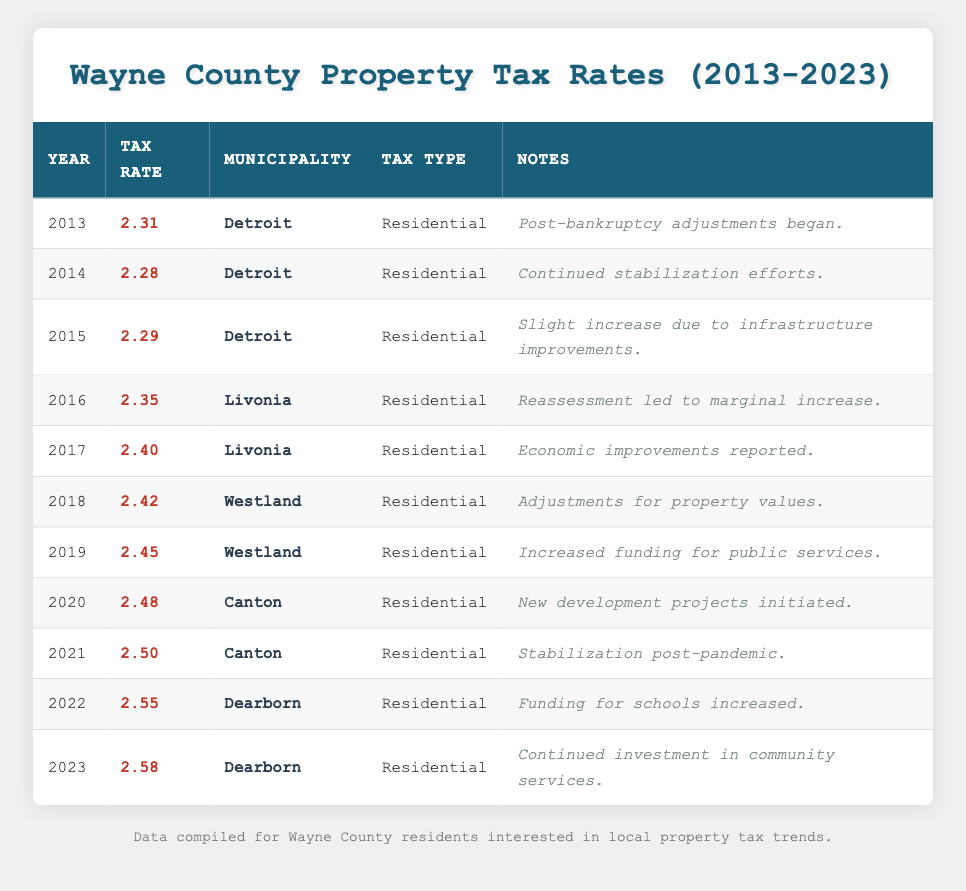What was the property tax rate in 2015 for Detroit? The table shows that in 2015, the Tax Rate for Detroit was listed as 2.29. This can be found directly under the Year 2015, in the respective row.
Answer: 2.29 What municipality had the highest property tax rate in 2021? In 2021, the Tax Rate for Canton was 2.50, making it the highest among the listed municipalities for that year, as no other municipality's rate is higher than this in the same year.
Answer: Canton Which year had the lowest property tax rate for Detroit, and what was the rate? The lowest property tax rate for Detroit was in 2014 at a rate of 2.28. By comparing the rates listed for all years pertaining to Detroit, 2014's rate is the lowest.
Answer: 2014, 2.28 What was the average property tax rate for Westland over the years 2018 and 2019? The tax rates for Westland are 2.42 for 2018 and 2.45 for 2019. To find the average, add these two rates: 2.42 + 2.45 = 4.87, and then divide by 2. So, the average is 4.87 / 2 = 2.435.
Answer: 2.435 Is it true that Dearborn's property tax rate increased every year from 2022 to 2023? Yes, the property tax rate for Dearborn increased from 2.55 in 2022 to 2.58 in 2023, which confirms the increase year-over-year.
Answer: Yes What is the difference in property tax rates between 2013 and 2023? The property tax rate in 2013 was 2.31, and in 2023 it is 2.58. To find the difference, subtract 2.31 from 2.58: 2.58 - 2.31 = 0.27.
Answer: 0.27 Which two years saw a tax rate increase for Canton, and what were those rates? Canton had increases noted in 2020 with a rate of 2.48 and again in 2021 with a rate of 2.50. This information is derived from the respective rows for those years.
Answer: 2020 (2.48), 2021 (2.50) What type of tax was listed for Livonia in both 2016 and 2017? The table shows that for both years, the type of tax for Livonia was labeled as Residential. This type remains consistent across both years in the table.
Answer: Residential What municipality had the highest tax rate increase from 2016 to 2017? Livonia had an increase from 2.35 in 2016 to 2.40 in 2017, which is a direct comparison giving an increase of 0.05. This makes Livonia the only municipality with an increase in that specific period.
Answer: Livonia 